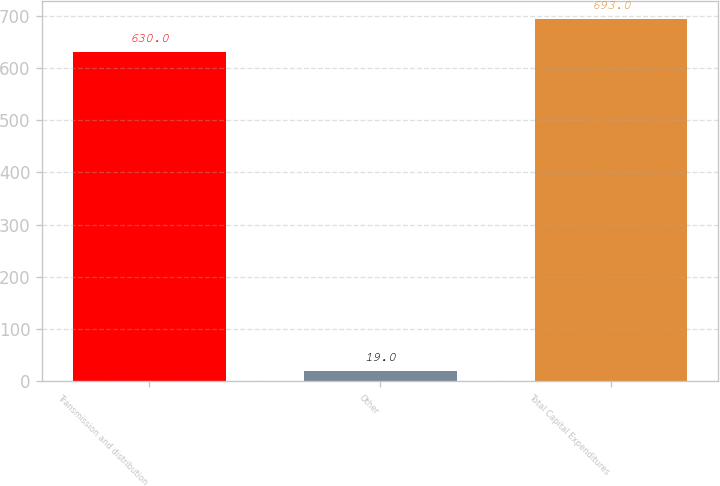<chart> <loc_0><loc_0><loc_500><loc_500><bar_chart><fcel>Transmission and distribution<fcel>Other<fcel>Total Capital Expenditures<nl><fcel>630<fcel>19<fcel>693<nl></chart> 